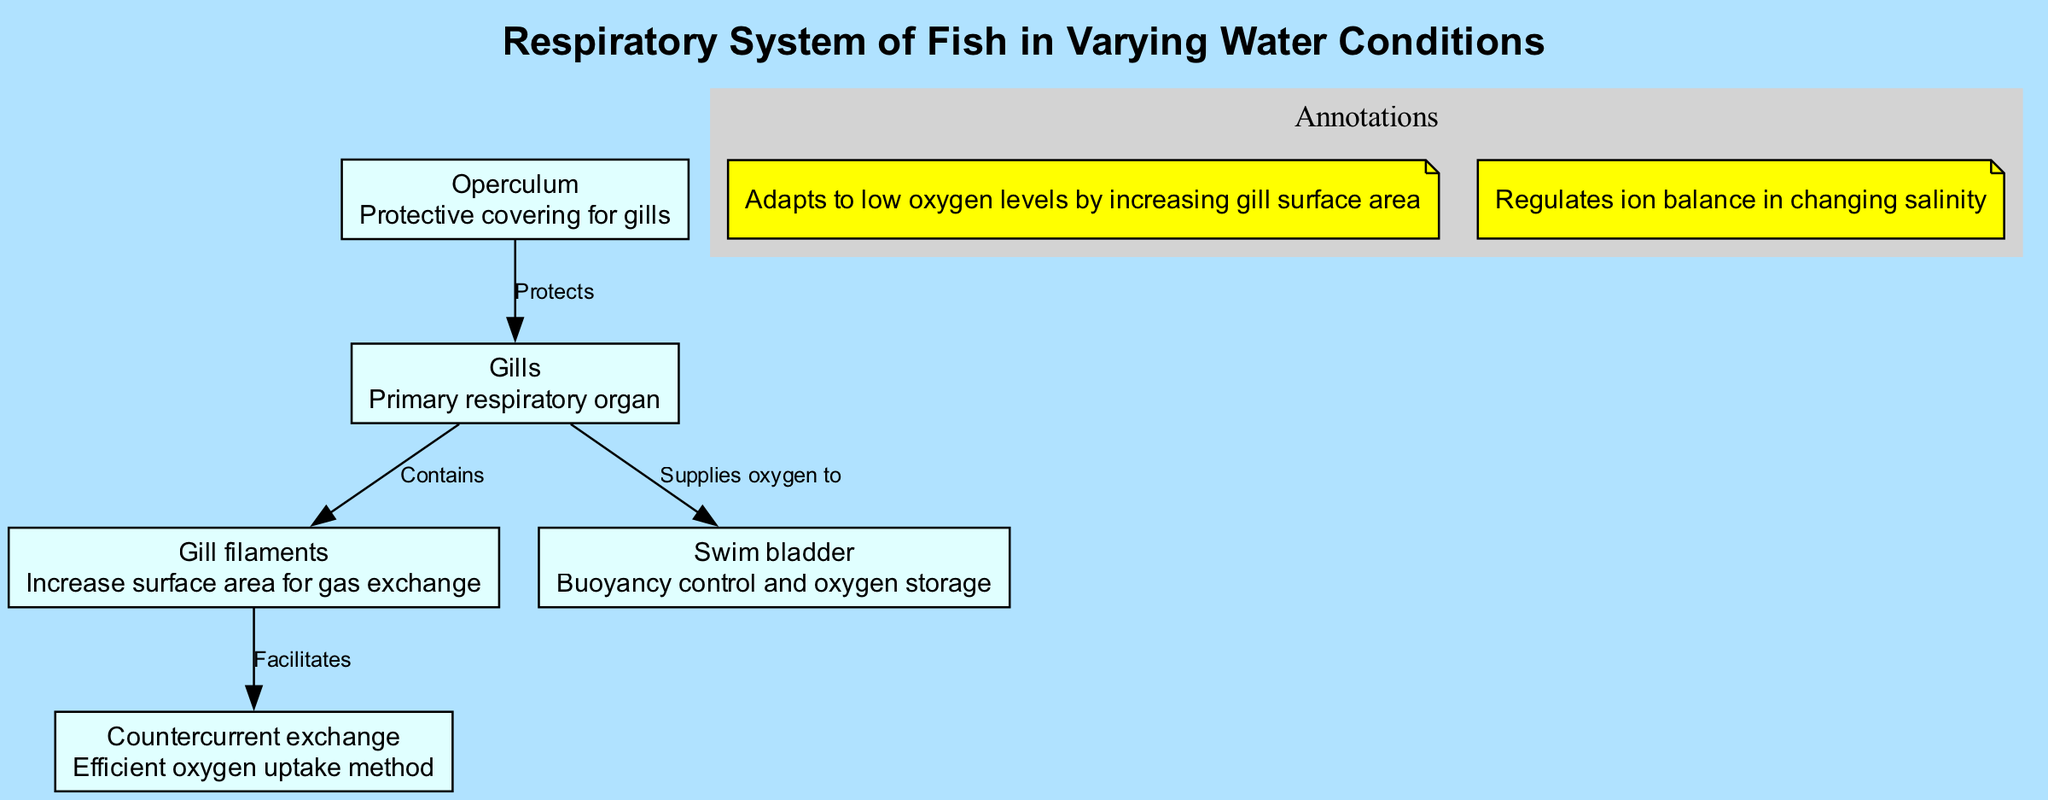What is the primary respiratory organ in fish? The diagram identifies "Gills" as the primary respiratory organ, making it clear that fish rely on these structures for respiration.
Answer: Gills How many nodes are in the diagram? By counting the nodes listed in the diagram, there are five nodes: Gills, Operculum, Gill filaments, Countercurrent exchange, and Swim bladder.
Answer: 5 What relationship does the Operculum have with the Gills? The diagram states that the Operculum "Protects" the Gills, indicating a protective function of this structure related to respiration.
Answer: Protects What role do Gill filaments play in the respiratory process? The description of "Gill filaments" states that they "Increase surface area for gas exchange," highlighting their importance in enhancing respiration efficiency.
Answer: Increase surface area for gas exchange What process facilitates oxygen uptake in fish? The "Countercurrent exchange" method is mentioned in the diagram as a mechanism that facilitates oxygen uptake, indicating its efficiency in respiratory function.
Answer: Countercurrent exchange How do fish adapt to low oxygen levels? The annotation in the diagram notes that fish "Adapts to low oxygen levels by increasing gill surface area," showing a specific physiological response to environmental conditions.
Answer: Increasing gill surface area Which structure supplies oxygen to the Swim bladder? The diagram indicates that the Gills "Supplies oxygen to" the Swim bladder, demonstrating the connection between these two components of the respiratory system.
Answer: Supplies oxygen to What is the function of the Swim bladder? The Swim bladder is described as a structure that provides "Buoyancy control and oxygen storage," outlining its dual role in the physiology of fish.
Answer: Buoyancy control and oxygen storage 